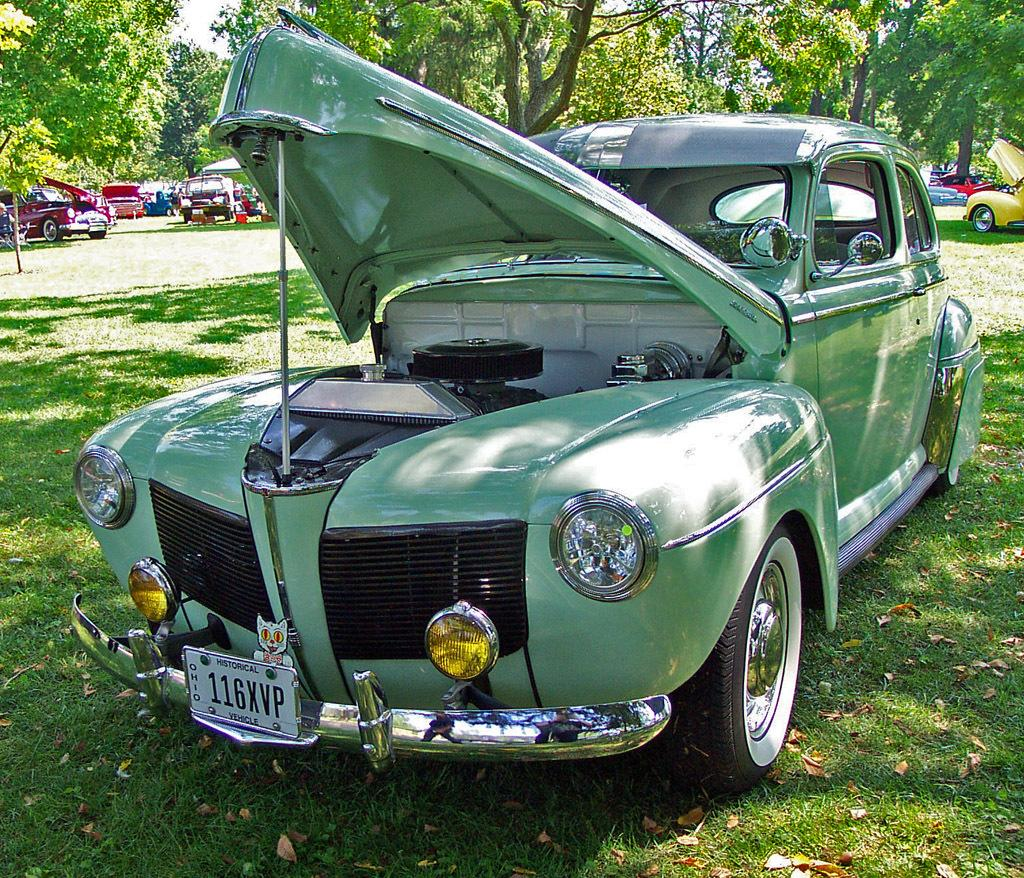What type of vehicle is in the image? There is an old vintage car in the image. What is the position of the car in the image? The car is on the ground. What is the state of the car's hood? The car's hood is open. What can be seen in the background of the image? There are trees in the background of the image. How many cars are visible on the ground in the image? There are multiple cars on the ground in the image. Can you tell me where the cactus is located in the image? There is no cactus present in the image. What type of railway is visible in the image? There is no railway present in the image. 